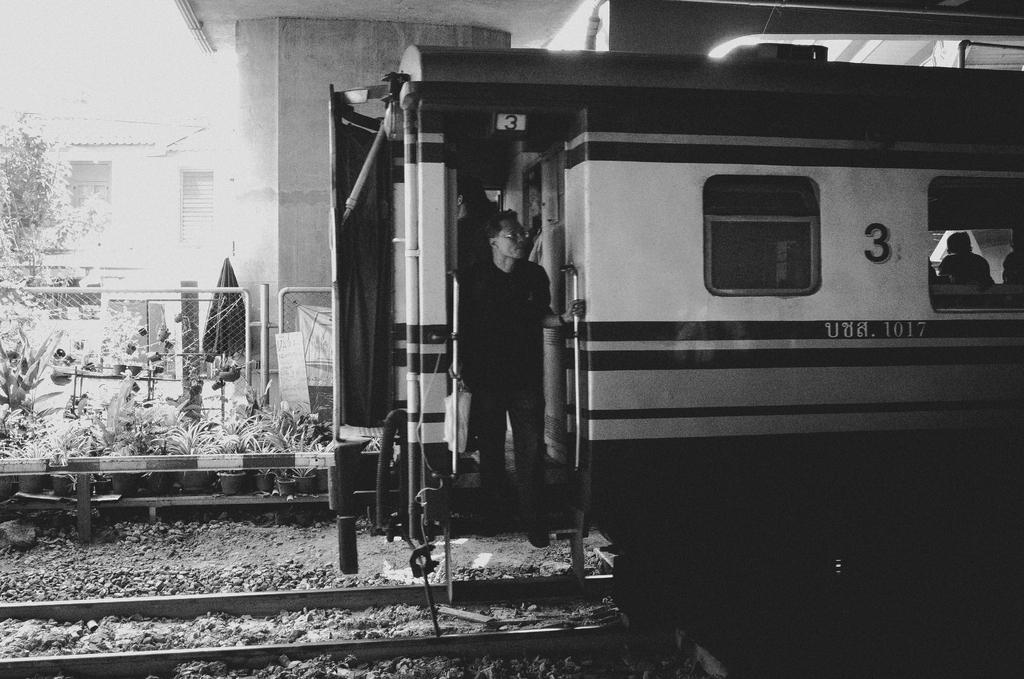What is the main subject of the image? The main subject of the image is a train on the railway track. Can you describe any other elements in the image? Yes, there is a man standing in the image, as well as buildings, plants, and a metal fence. What type of appliance is being used to commit a crime in the image? There is no appliance or crime present in the image; it features a train on a railway track, a man standing, buildings, plants, and a metal fence. 